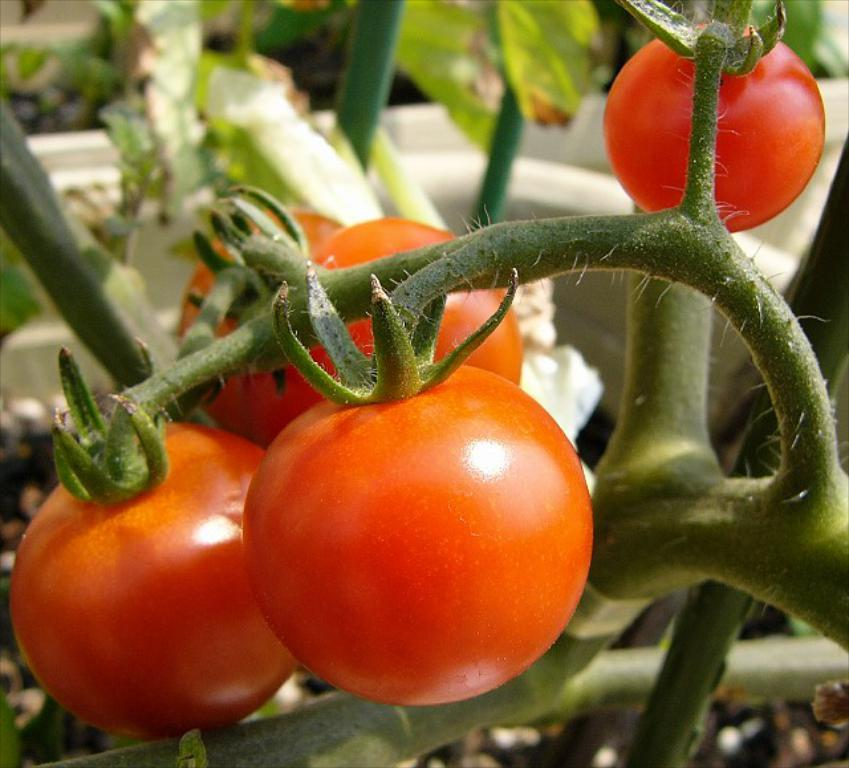What type of fruit can be seen on the branches in the image? There are red color tomatoes on the branches in the image. What else can be seen on the branches besides the tomatoes? There are leaves visible in the image. What color is the object in the background of the image? There is a white color object in the background of the image. Can you tell me how the tomatoes are stopping the snow from falling in the image? There is no snow present in the image, and the tomatoes are not stopping any snow from falling. 